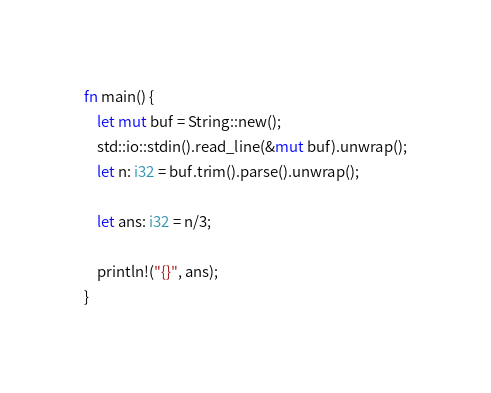<code> <loc_0><loc_0><loc_500><loc_500><_Rust_>fn main() {
    let mut buf = String::new();
    std::io::stdin().read_line(&mut buf).unwrap();
    let n: i32 = buf.trim().parse().unwrap();

    let ans: i32 = n/3;

    println!("{}", ans);
}
</code> 